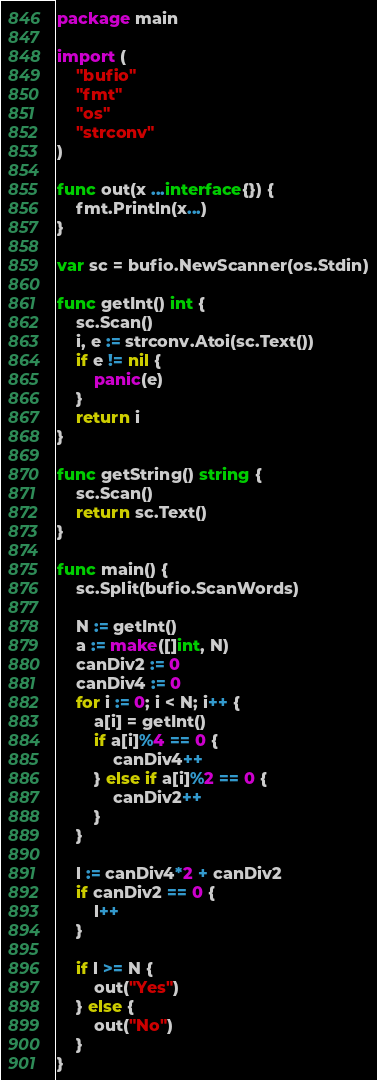Convert code to text. <code><loc_0><loc_0><loc_500><loc_500><_Go_>package main

import (
	"bufio"
	"fmt"
	"os"
	"strconv"
)

func out(x ...interface{}) {
	fmt.Println(x...)
}

var sc = bufio.NewScanner(os.Stdin)

func getInt() int {
	sc.Scan()
	i, e := strconv.Atoi(sc.Text())
	if e != nil {
		panic(e)
	}
	return i
}

func getString() string {
	sc.Scan()
	return sc.Text()
}

func main() {
	sc.Split(bufio.ScanWords)

	N := getInt()
	a := make([]int, N)
	canDiv2 := 0
	canDiv4 := 0
	for i := 0; i < N; i++ {
		a[i] = getInt()
		if a[i]%4 == 0 {
			canDiv4++
		} else if a[i]%2 == 0 {
			canDiv2++
		}
	}

	l := canDiv4*2 + canDiv2
	if canDiv2 == 0 {
		l++
	}

	if l >= N {
		out("Yes")
	} else {
		out("No")
	}
}
</code> 